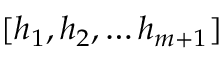Convert formula to latex. <formula><loc_0><loc_0><loc_500><loc_500>[ h _ { 1 } , h _ { 2 } , \dots h _ { m + 1 } ]</formula> 